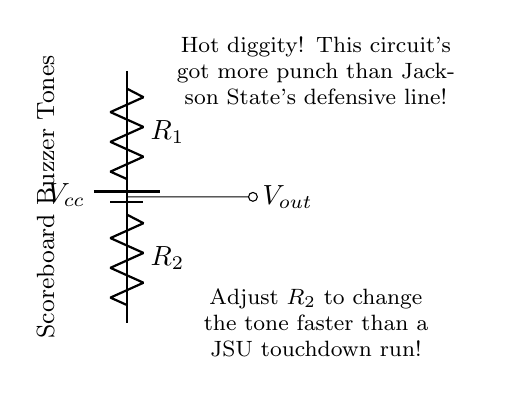What is the type of this circuit? The circuit is a voltage divider, which is designed to produce a specific output voltage from a higher input voltage by dividing it through resistors.
Answer: voltage divider What are the resistors used in this circuit? The resistors in the circuit are identified as R1 and R2, which are components used to create the voltage division.
Answer: R1 and R2 What does Vout represent in this circuit? Vout represents the output voltage from the voltage divider, which is taken across R2 according to the voltage divider rule.
Answer: output voltage How can the tone change in this circuit? The tone can be changed by adjusting the value of R2, which influences the amount of voltage dropped across it and therefore the output tone played by the buzzer.
Answer: Adjusting R2 What is the function of the battery? The battery provides the supply voltage (Vcc) necessary for the operation of the circuit and the buzzer.
Answer: Power supply What happens if R2 is increased? If R2 is increased, the output voltage Vout will increase towards Vcc, resulting in a higher tone generated by the buzzer.
Answer: Vout increases How is the output tone related to the resistor values? The output tone is determined by the ratio of R1 to R2, which defines the output voltage based on the input voltage, affecting the buzzer's frequency.
Answer: R1 and R2 ratio 